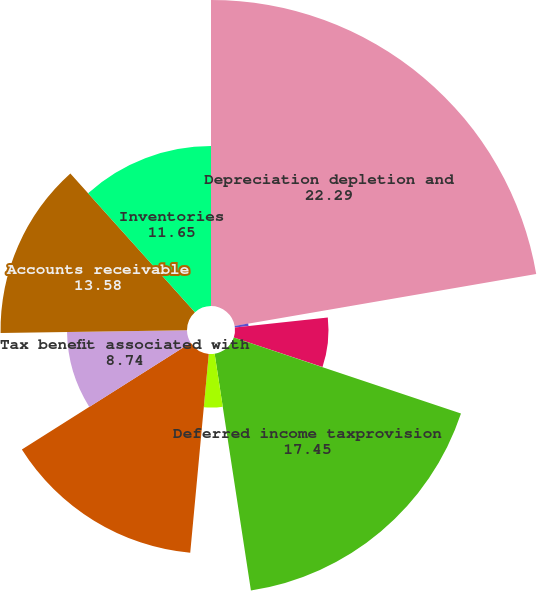<chart> <loc_0><loc_0><loc_500><loc_500><pie_chart><fcel>Depreciation depletion and<fcel>Amortization of financingcosts<fcel>Amortization of Treasury lock<fcel>Amortization of unearned<fcel>Deferred income taxprovision<fcel>Loss on disposals ofproperty<fcel>Gain fromjoint venture<fcel>Tax benefit associated with<fcel>Accounts receivable<fcel>Inventories<nl><fcel>22.29%<fcel>1.0%<fcel>6.81%<fcel>0.03%<fcel>17.45%<fcel>3.9%<fcel>14.55%<fcel>8.74%<fcel>13.58%<fcel>11.65%<nl></chart> 